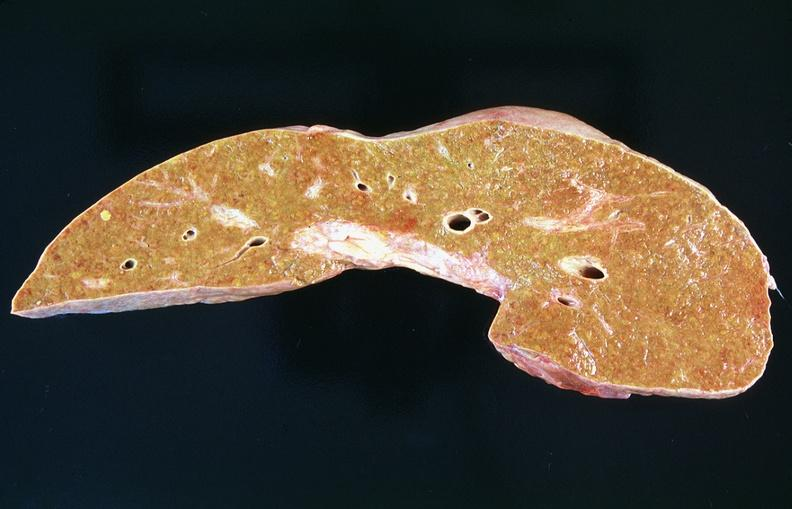does this image show liver, cirrhosis alpha-1 antitrypsin deficiency?
Answer the question using a single word or phrase. Yes 